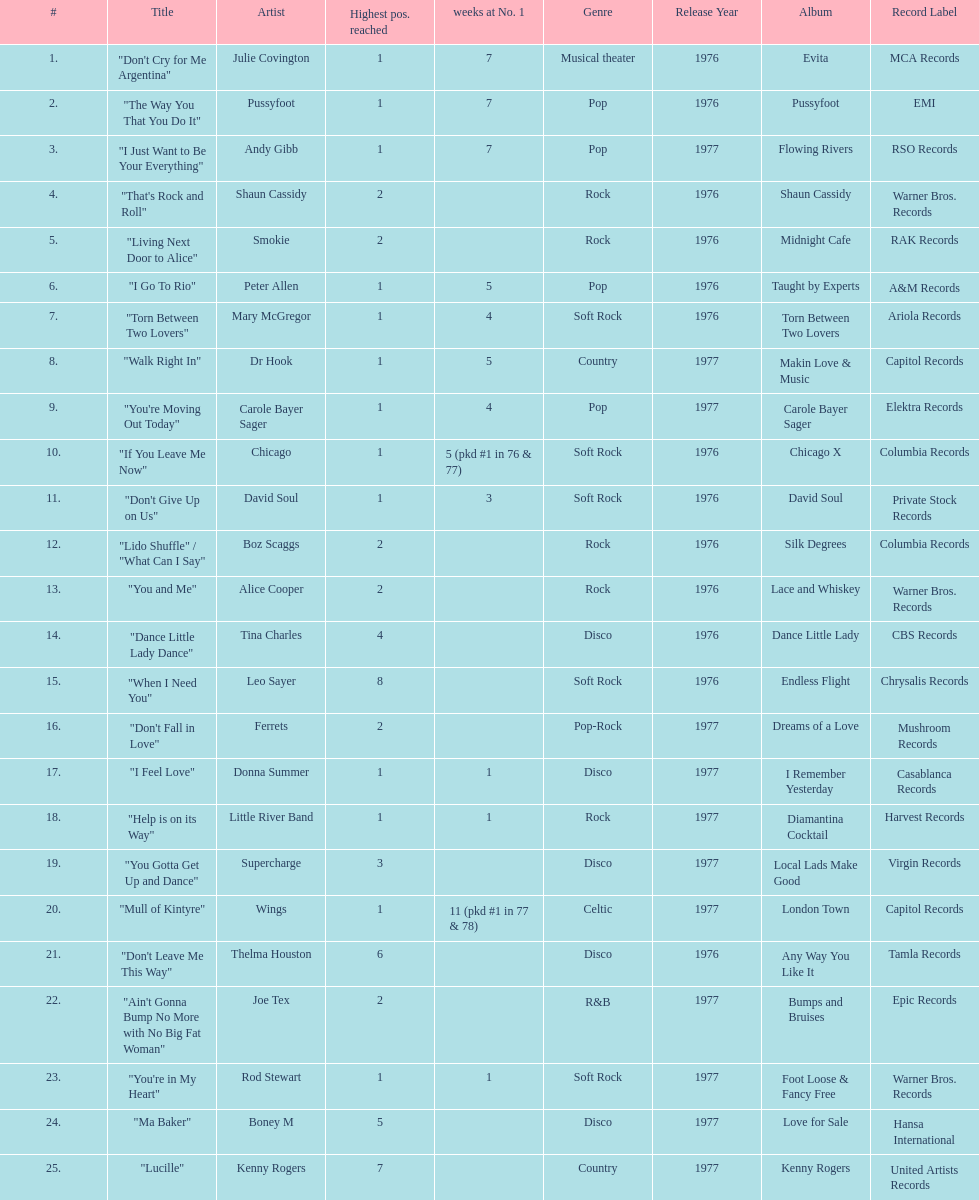Who had the most weeks at number one, according to the table? Wings. 